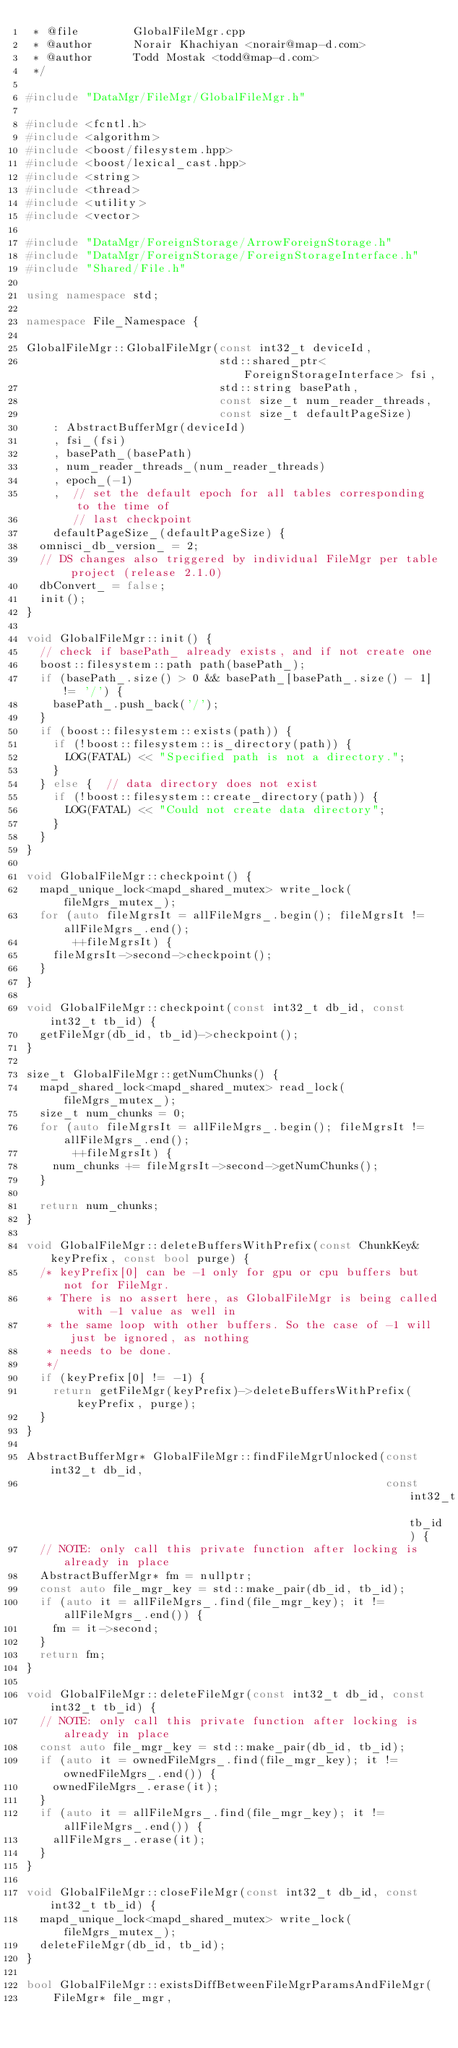Convert code to text. <code><loc_0><loc_0><loc_500><loc_500><_C++_> * @file        GlobalFileMgr.cpp
 * @author      Norair Khachiyan <norair@map-d.com>
 * @author      Todd Mostak <todd@map-d.com>
 */

#include "DataMgr/FileMgr/GlobalFileMgr.h"

#include <fcntl.h>
#include <algorithm>
#include <boost/filesystem.hpp>
#include <boost/lexical_cast.hpp>
#include <string>
#include <thread>
#include <utility>
#include <vector>

#include "DataMgr/ForeignStorage/ArrowForeignStorage.h"
#include "DataMgr/ForeignStorage/ForeignStorageInterface.h"
#include "Shared/File.h"

using namespace std;

namespace File_Namespace {

GlobalFileMgr::GlobalFileMgr(const int32_t deviceId,
                             std::shared_ptr<ForeignStorageInterface> fsi,
                             std::string basePath,
                             const size_t num_reader_threads,
                             const size_t defaultPageSize)
    : AbstractBufferMgr(deviceId)
    , fsi_(fsi)
    , basePath_(basePath)
    , num_reader_threads_(num_reader_threads)
    , epoch_(-1)
    ,  // set the default epoch for all tables corresponding to the time of
       // last checkpoint
    defaultPageSize_(defaultPageSize) {
  omnisci_db_version_ = 2;
  // DS changes also triggered by individual FileMgr per table project (release 2.1.0)
  dbConvert_ = false;
  init();
}

void GlobalFileMgr::init() {
  // check if basePath_ already exists, and if not create one
  boost::filesystem::path path(basePath_);
  if (basePath_.size() > 0 && basePath_[basePath_.size() - 1] != '/') {
    basePath_.push_back('/');
  }
  if (boost::filesystem::exists(path)) {
    if (!boost::filesystem::is_directory(path)) {
      LOG(FATAL) << "Specified path is not a directory.";
    }
  } else {  // data directory does not exist
    if (!boost::filesystem::create_directory(path)) {
      LOG(FATAL) << "Could not create data directory";
    }
  }
}

void GlobalFileMgr::checkpoint() {
  mapd_unique_lock<mapd_shared_mutex> write_lock(fileMgrs_mutex_);
  for (auto fileMgrsIt = allFileMgrs_.begin(); fileMgrsIt != allFileMgrs_.end();
       ++fileMgrsIt) {
    fileMgrsIt->second->checkpoint();
  }
}

void GlobalFileMgr::checkpoint(const int32_t db_id, const int32_t tb_id) {
  getFileMgr(db_id, tb_id)->checkpoint();
}

size_t GlobalFileMgr::getNumChunks() {
  mapd_shared_lock<mapd_shared_mutex> read_lock(fileMgrs_mutex_);
  size_t num_chunks = 0;
  for (auto fileMgrsIt = allFileMgrs_.begin(); fileMgrsIt != allFileMgrs_.end();
       ++fileMgrsIt) {
    num_chunks += fileMgrsIt->second->getNumChunks();
  }

  return num_chunks;
}

void GlobalFileMgr::deleteBuffersWithPrefix(const ChunkKey& keyPrefix, const bool purge) {
  /* keyPrefix[0] can be -1 only for gpu or cpu buffers but not for FileMgr.
   * There is no assert here, as GlobalFileMgr is being called with -1 value as well in
   * the same loop with other buffers. So the case of -1 will just be ignored, as nothing
   * needs to be done.
   */
  if (keyPrefix[0] != -1) {
    return getFileMgr(keyPrefix)->deleteBuffersWithPrefix(keyPrefix, purge);
  }
}

AbstractBufferMgr* GlobalFileMgr::findFileMgrUnlocked(const int32_t db_id,
                                                      const int32_t tb_id) {
  // NOTE: only call this private function after locking is already in place
  AbstractBufferMgr* fm = nullptr;
  const auto file_mgr_key = std::make_pair(db_id, tb_id);
  if (auto it = allFileMgrs_.find(file_mgr_key); it != allFileMgrs_.end()) {
    fm = it->second;
  }
  return fm;
}

void GlobalFileMgr::deleteFileMgr(const int32_t db_id, const int32_t tb_id) {
  // NOTE: only call this private function after locking is already in place
  const auto file_mgr_key = std::make_pair(db_id, tb_id);
  if (auto it = ownedFileMgrs_.find(file_mgr_key); it != ownedFileMgrs_.end()) {
    ownedFileMgrs_.erase(it);
  }
  if (auto it = allFileMgrs_.find(file_mgr_key); it != allFileMgrs_.end()) {
    allFileMgrs_.erase(it);
  }
}

void GlobalFileMgr::closeFileMgr(const int32_t db_id, const int32_t tb_id) {
  mapd_unique_lock<mapd_shared_mutex> write_lock(fileMgrs_mutex_);
  deleteFileMgr(db_id, tb_id);
}

bool GlobalFileMgr::existsDiffBetweenFileMgrParamsAndFileMgr(
    FileMgr* file_mgr,</code> 